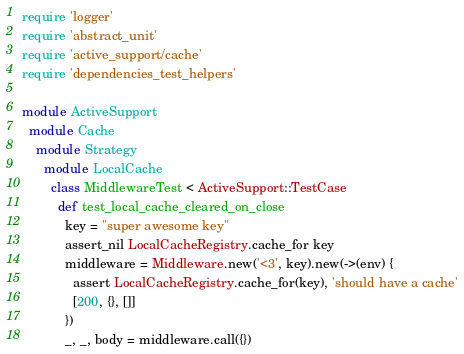<code> <loc_0><loc_0><loc_500><loc_500><_Ruby_>require 'logger'
require 'abstract_unit'
require 'active_support/cache'
require 'dependencies_test_helpers'

module ActiveSupport
  module Cache
    module Strategy
      module LocalCache
        class MiddlewareTest < ActiveSupport::TestCase
          def test_local_cache_cleared_on_close
            key = "super awesome key"
            assert_nil LocalCacheRegistry.cache_for key
            middleware = Middleware.new('<3', key).new(->(env) {
              assert LocalCacheRegistry.cache_for(key), 'should have a cache'
              [200, {}, []]
            })
            _, _, body = middleware.call({})</code> 